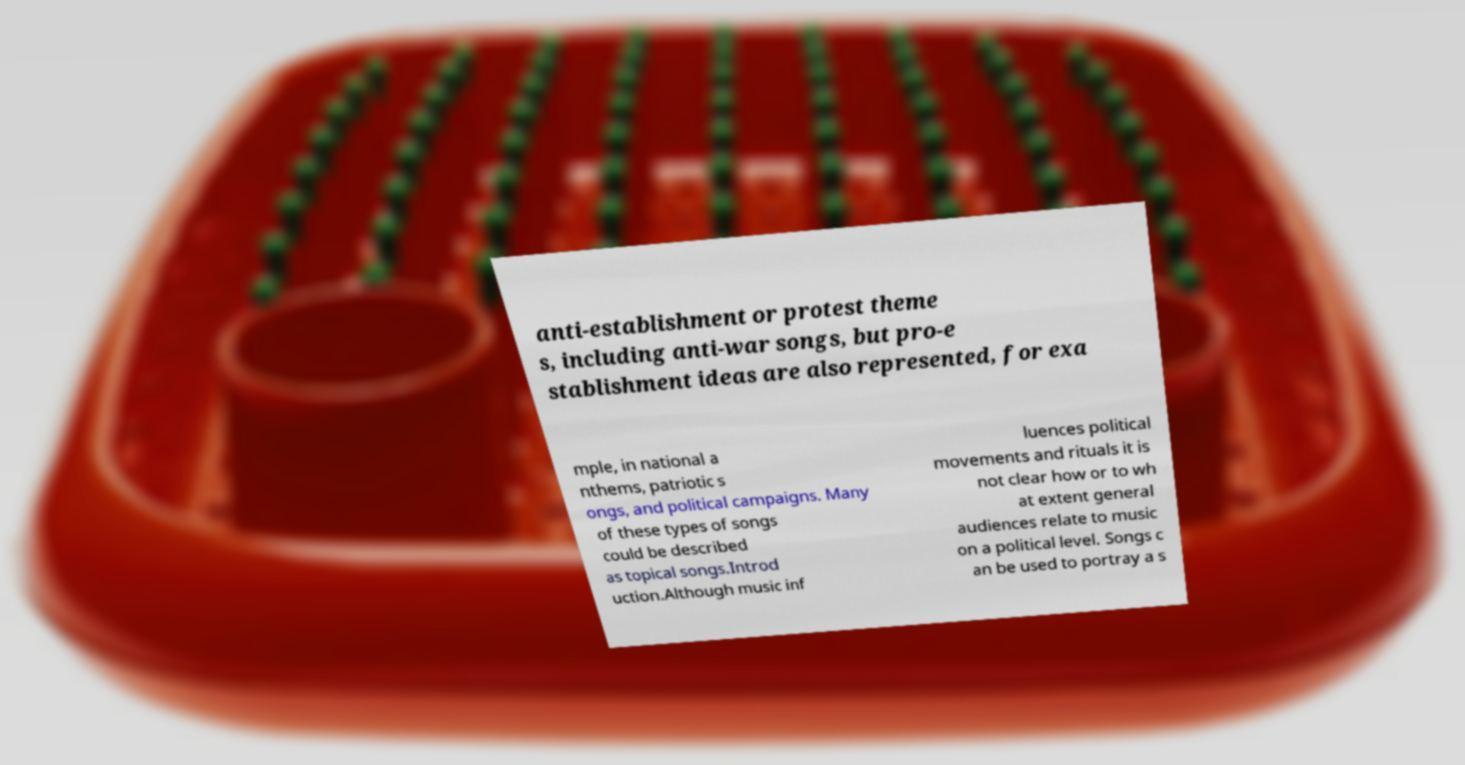What messages or text are displayed in this image? I need them in a readable, typed format. anti-establishment or protest theme s, including anti-war songs, but pro-e stablishment ideas are also represented, for exa mple, in national a nthems, patriotic s ongs, and political campaigns. Many of these types of songs could be described as topical songs.Introd uction.Although music inf luences political movements and rituals it is not clear how or to wh at extent general audiences relate to music on a political level. Songs c an be used to portray a s 